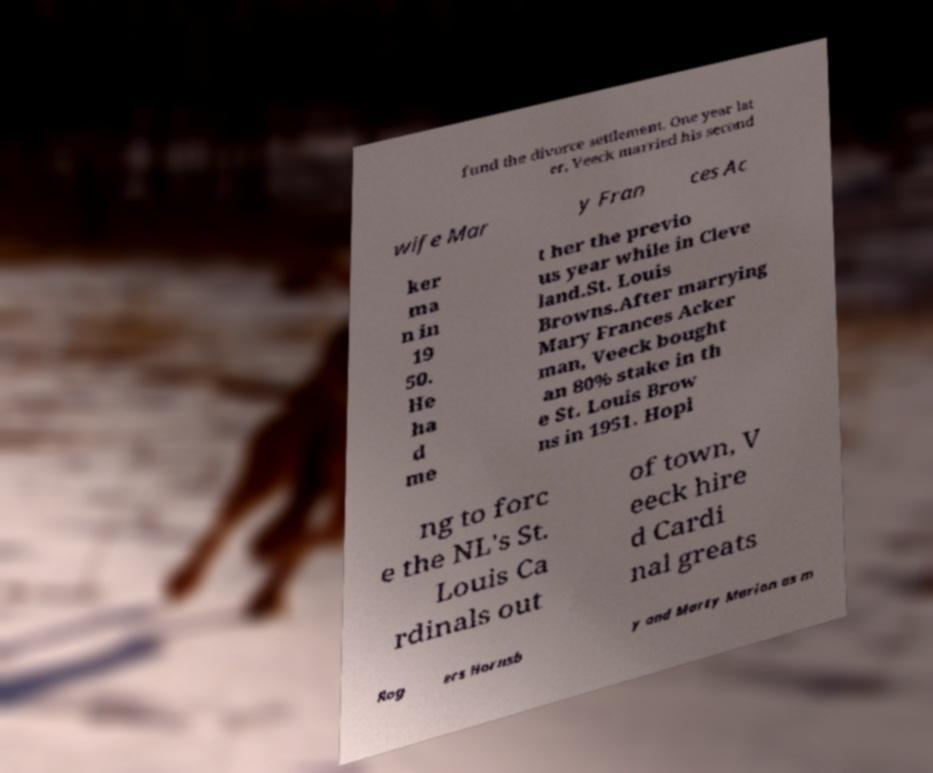I need the written content from this picture converted into text. Can you do that? fund the divorce settlement. One year lat er, Veeck married his second wife Mar y Fran ces Ac ker ma n in 19 50. He ha d me t her the previo us year while in Cleve land.St. Louis Browns.After marrying Mary Frances Acker man, Veeck bought an 80% stake in th e St. Louis Brow ns in 1951. Hopi ng to forc e the NL's St. Louis Ca rdinals out of town, V eeck hire d Cardi nal greats Rog ers Hornsb y and Marty Marion as m 